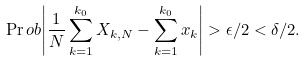<formula> <loc_0><loc_0><loc_500><loc_500>\Pr o b { \left | \frac { 1 } { N } \sum _ { k = 1 } ^ { k _ { 0 } } X _ { k , N } - \sum _ { k = 1 } ^ { k _ { 0 } } x _ { k } \right | > \epsilon / 2 } < \delta / 2 .</formula> 